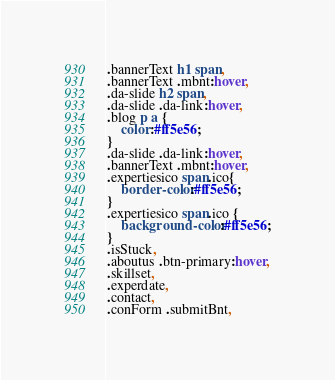<code> <loc_0><loc_0><loc_500><loc_500><_CSS_>.bannerText h1 span,
.bannerText .mbnt:hover,
.da-slide h2 span,
.da-slide .da-link:hover,
.blog p a {
	color:#ff5e56;
}
.da-slide .da-link:hover,
.bannerText .mbnt:hover,
.expertiesico span.ico{
	border-color:#ff5e56;
}
.expertiesico span.ico {
	background-color:#ff5e56;
}
.isStuck,
.aboutus .btn-primary:hover,
.skillset,
.experdate,
.contact,
.conForm .submitBnt,</code> 